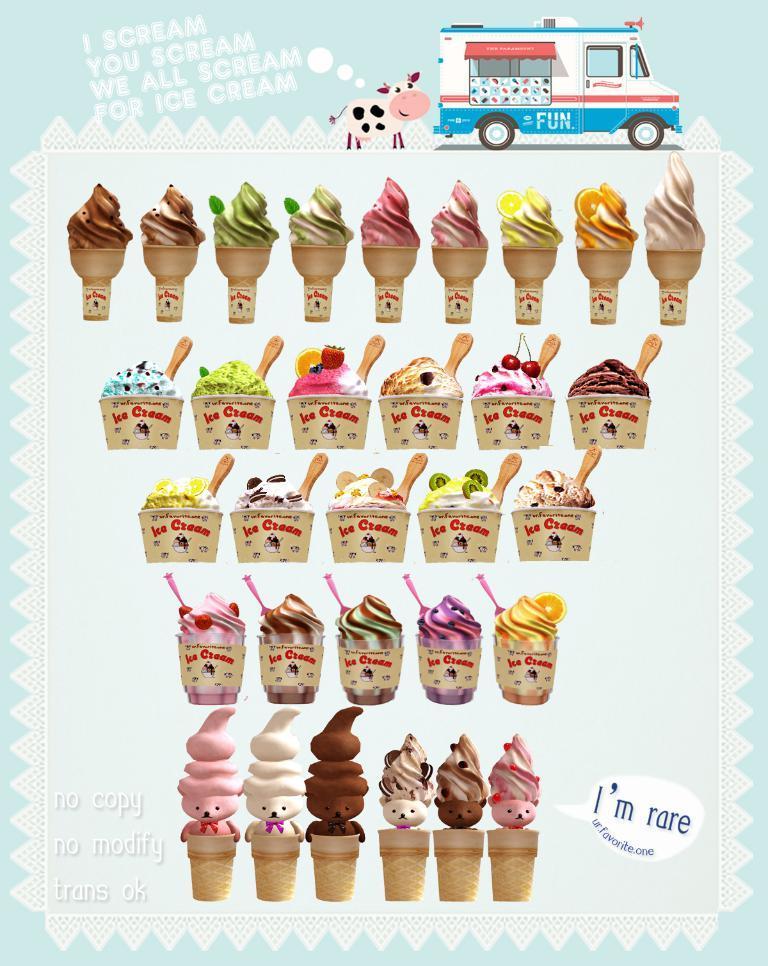Could you give a brief overview of what you see in this image? In this image we can see ice creams. At the top we can see van. 